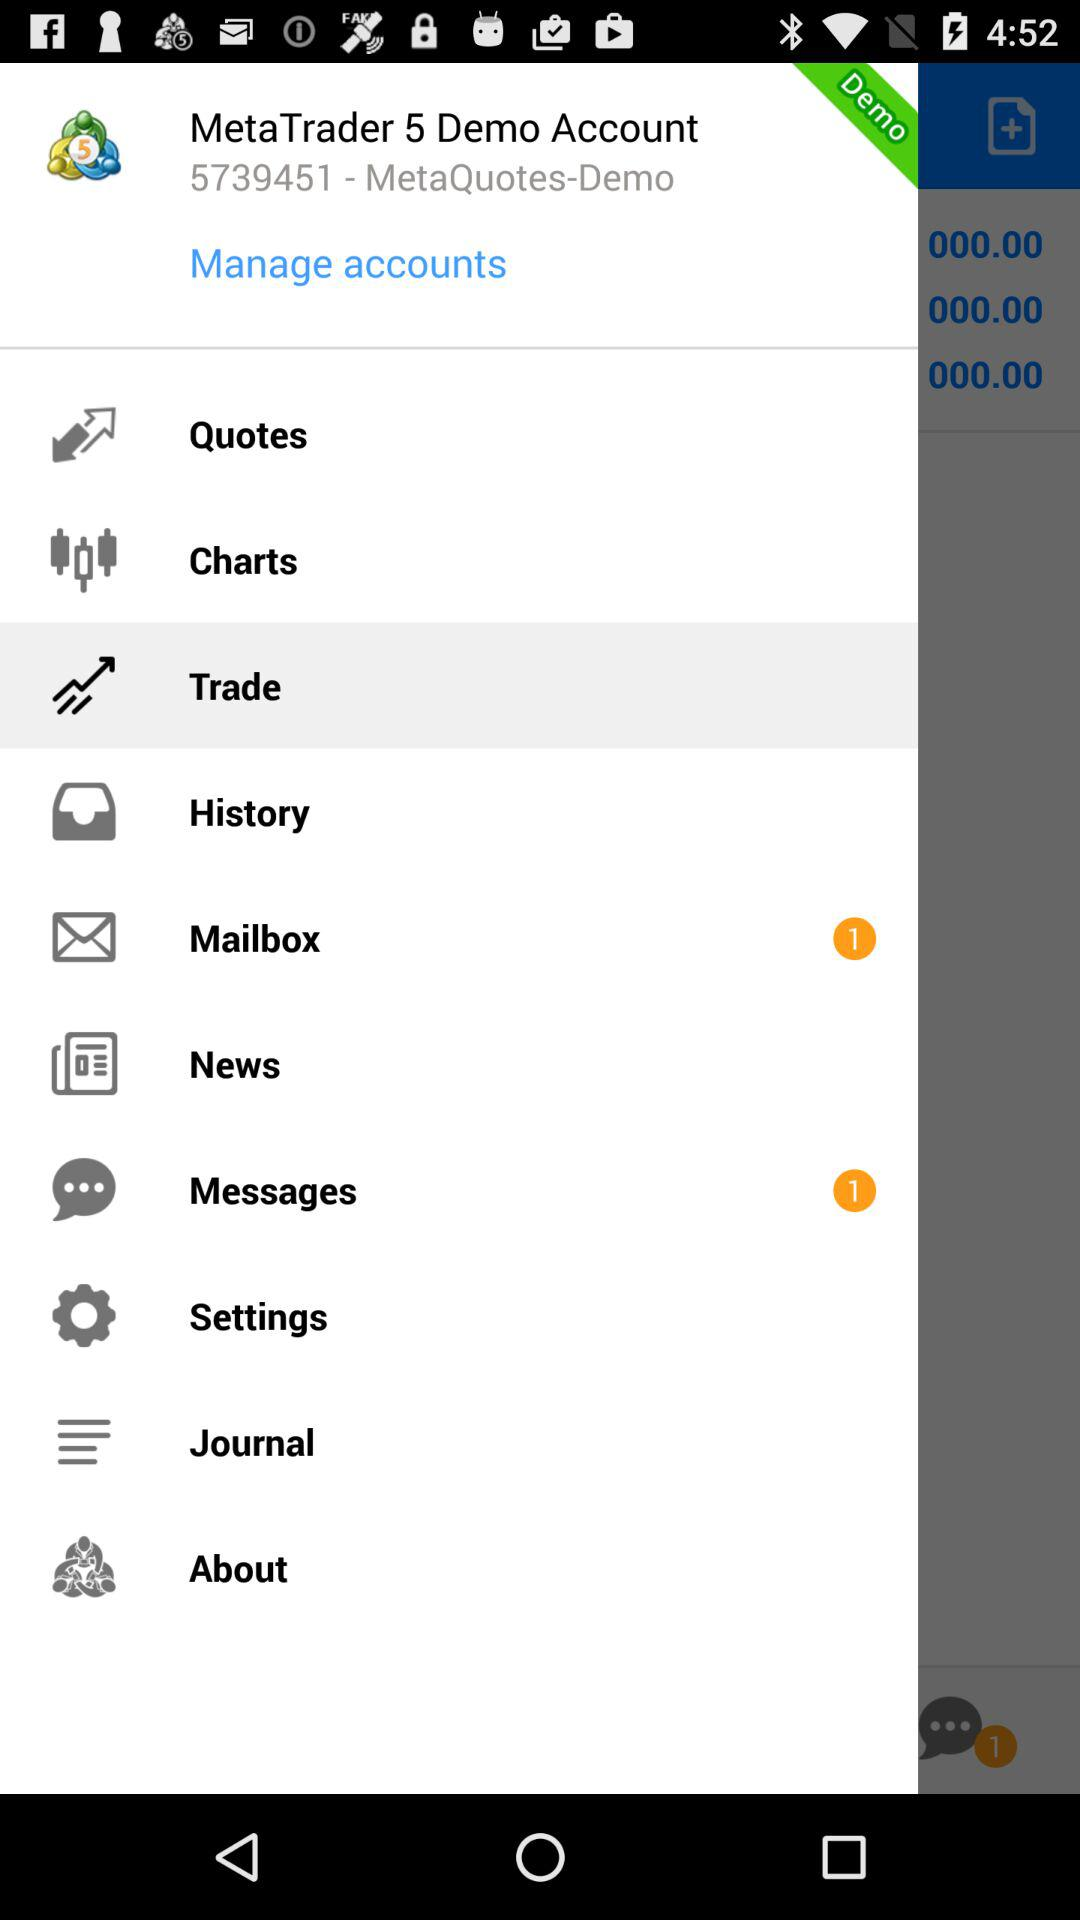What is the number of the demo account? The number of the demo account is 5739451. 